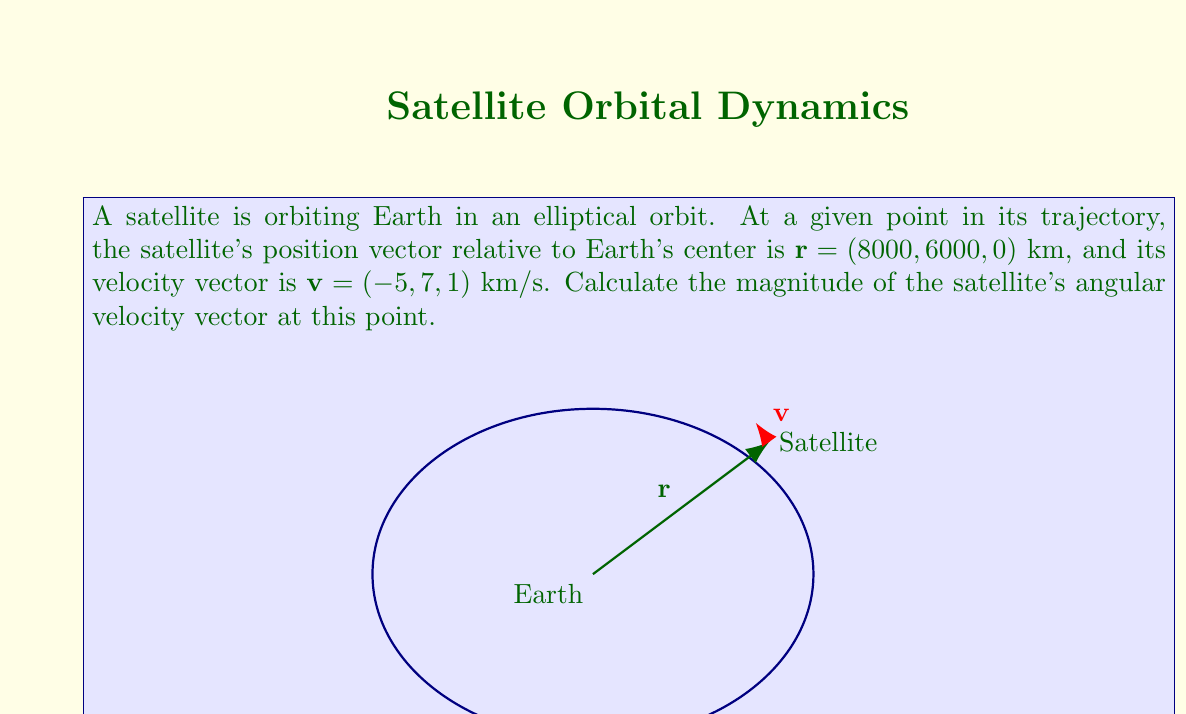Help me with this question. To solve this problem, we'll follow these steps:

1) The angular velocity vector $\mathbf{\omega}$ is related to the position vector $\mathbf{r}$ and velocity vector $\mathbf{v}$ by the cross product:

   $$\mathbf{r} \times \mathbf{v} = \mathbf{r}^2 \mathbf{\omega}$$

2) We need to calculate the cross product $\mathbf{r} \times \mathbf{v}$:

   $$\mathbf{r} \times \mathbf{v} = \begin{vmatrix} 
   \mathbf{i} & \mathbf{j} & \mathbf{k} \\
   8000 & 6000 & 0 \\
   -5 & 7 & 1
   \end{vmatrix}$$

   $$ = (6000 \cdot 1 - 0 \cdot 7)\mathbf{i} - (8000 \cdot 1 - 0 \cdot (-5))\mathbf{j} + (8000 \cdot 7 - 6000 \cdot (-5))\mathbf{k}$$

   $$ = 6000\mathbf{i} - 8000\mathbf{j} + 86000\mathbf{k}$$

3) Calculate the magnitude of $\mathbf{r}$:

   $$|\mathbf{r}| = \sqrt{8000^2 + 6000^2 + 0^2} = 10000 \text{ km}$$

4) The magnitude of the angular velocity is:

   $$|\mathbf{\omega}| = \frac{|\mathbf{r} \times \mathbf{v}|}{|\mathbf{r}|^2}$$

5) Calculate $|\mathbf{r} \times \mathbf{v}|$:

   $$|\mathbf{r} \times \mathbf{v}| = \sqrt{6000^2 + (-8000)^2 + 86000^2} = 86,721.5 \text{ km}^2/s$$

6) Finally, calculate $|\mathbf{\omega}|$:

   $$|\mathbf{\omega}| = \frac{86,721.5}{10000^2} = 0.0008672 \text{ rad/s}$$
Answer: $0.0008672 \text{ rad/s}$ 